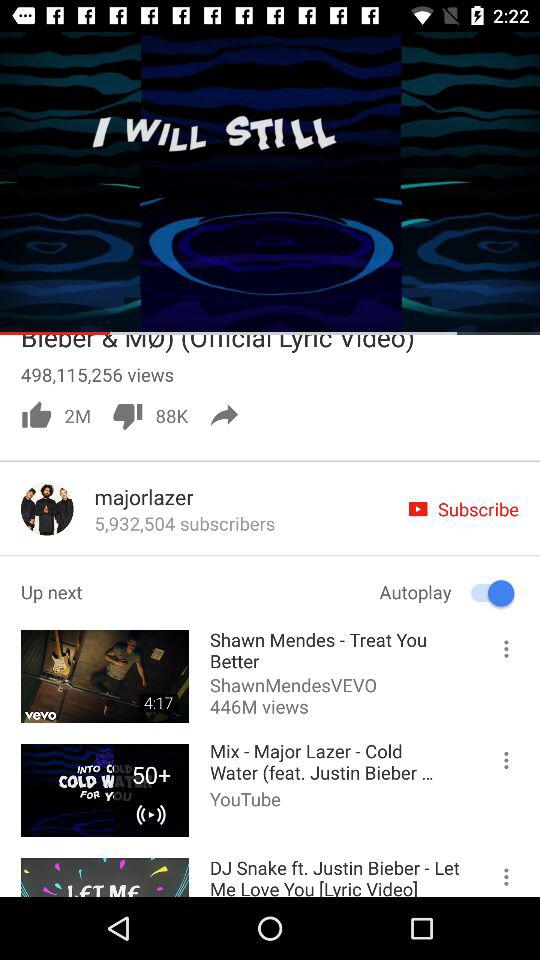How many likes did "Coldplay - Hymn For The Weekend" get? "Coldplay - Hymn For The Weekend" got 3 million likes. 